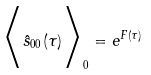<formula> <loc_0><loc_0><loc_500><loc_500>\Big < \hat { s } _ { 0 0 } ( \tau ) \Big > _ { 0 } = e ^ { F ( \tau ) }</formula> 